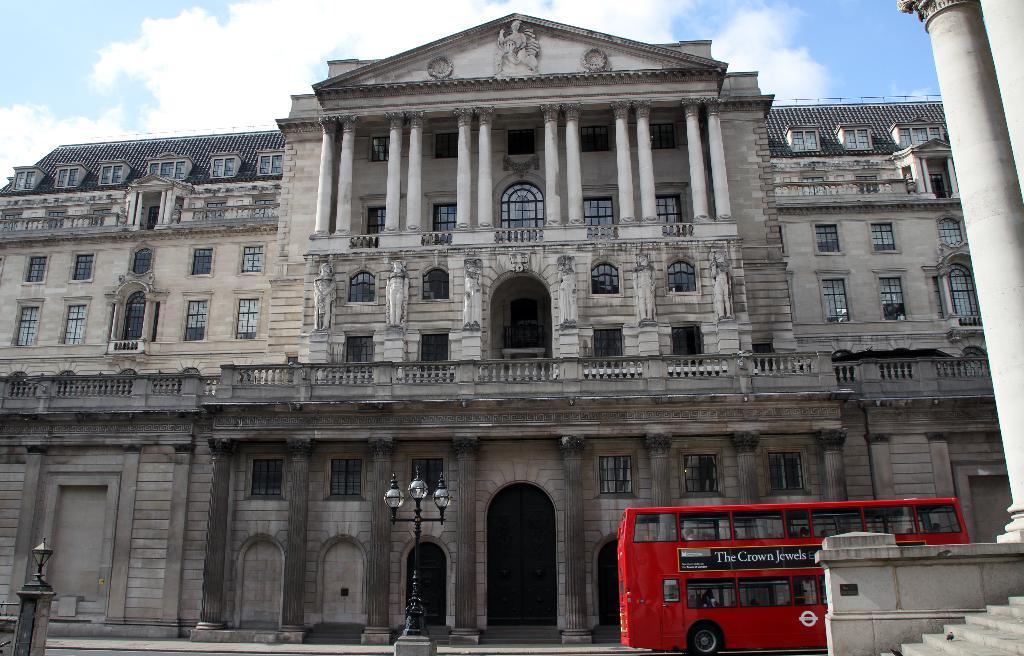What structure is located on the left side of the image? There is a staircase, a pillar, and a bus on the left side of the image. What can be seen in the middle of the image? There is a street light in the middle of the image. What is the main building in the image? There is a building in the center of the image. What is visible at the top of the image? The sky is visible at the top of the image. How many eggs are present in the image? There are no eggs visible in the image. What time of day is it in the image, given that it is morning? The time of day cannot be determined from the image, and there is no indication that it is morning. 